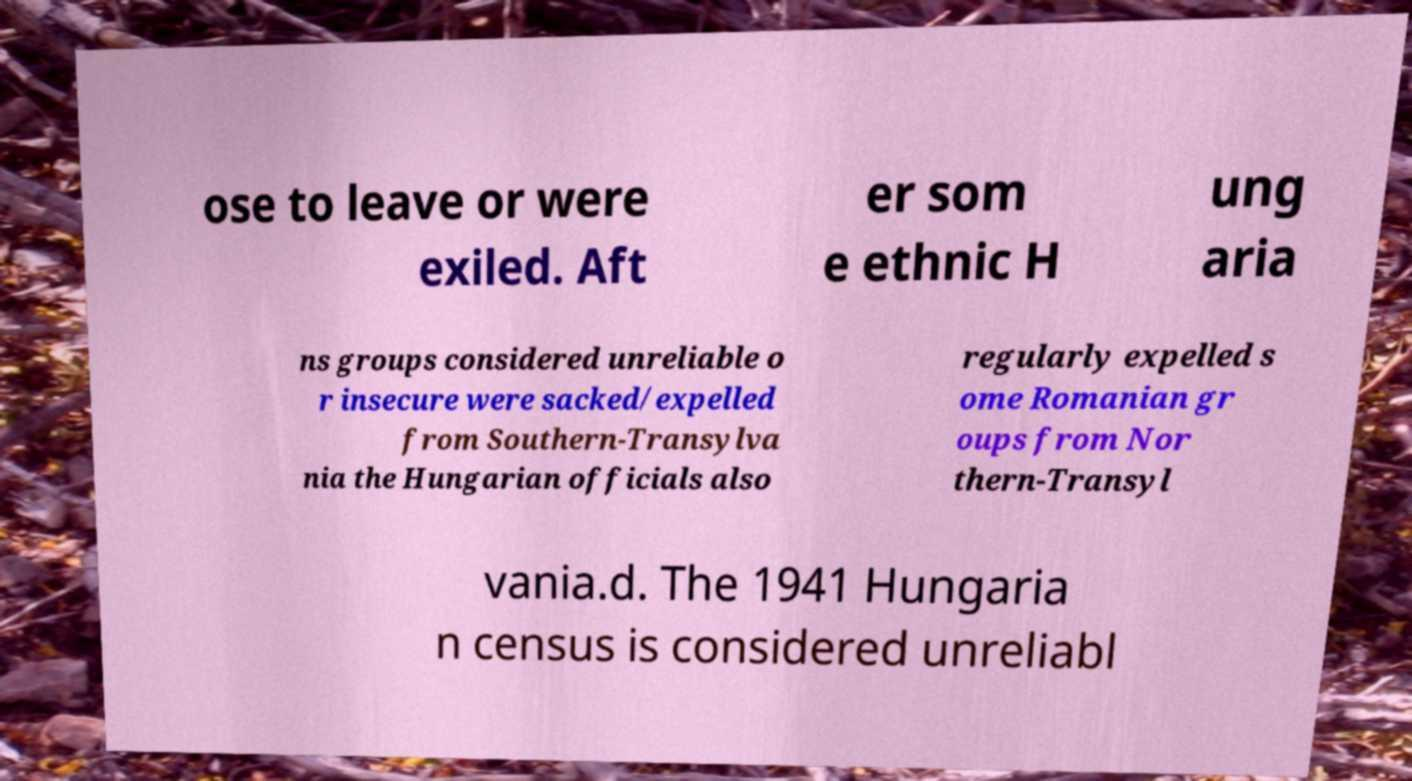Can you read and provide the text displayed in the image?This photo seems to have some interesting text. Can you extract and type it out for me? ose to leave or were exiled. Aft er som e ethnic H ung aria ns groups considered unreliable o r insecure were sacked/expelled from Southern-Transylva nia the Hungarian officials also regularly expelled s ome Romanian gr oups from Nor thern-Transyl vania.d. The 1941 Hungaria n census is considered unreliabl 